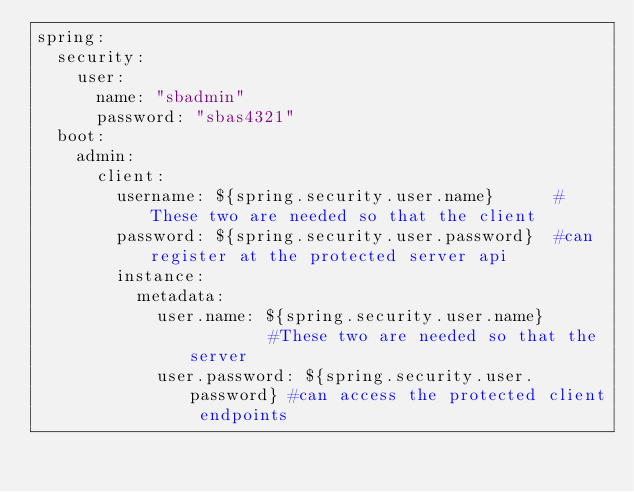<code> <loc_0><loc_0><loc_500><loc_500><_YAML_>spring:
  security:
    user:
      name: "sbadmin"
      password: "sbas4321"
  boot:
    admin:
      client:
        username: ${spring.security.user.name}      #These two are needed so that the client
        password: ${spring.security.user.password}  #can register at the protected server api
        instance:
          metadata:
            user.name: ${spring.security.user.name}         #These two are needed so that the server
            user.password: ${spring.security.user.password} #can access the protected client endpoints
</code> 